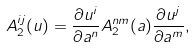<formula> <loc_0><loc_0><loc_500><loc_500>A _ { 2 } ^ { i j } ( u ) = \frac { \partial u ^ { i } } { \partial a ^ { n } } A ^ { n m } _ { 2 } ( a ) \frac { \partial u ^ { j } } { \partial a ^ { m } } ,</formula> 